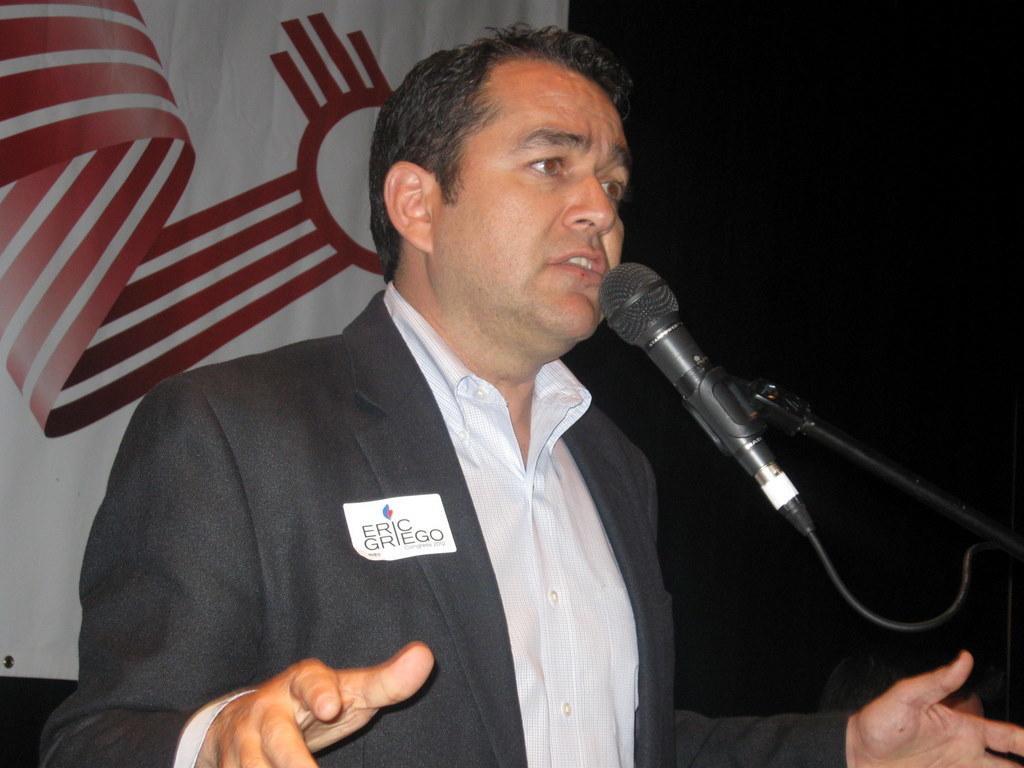Can you describe this image briefly? In this image there is a person on the stage, a microphone to a stand and a poster with some image. 